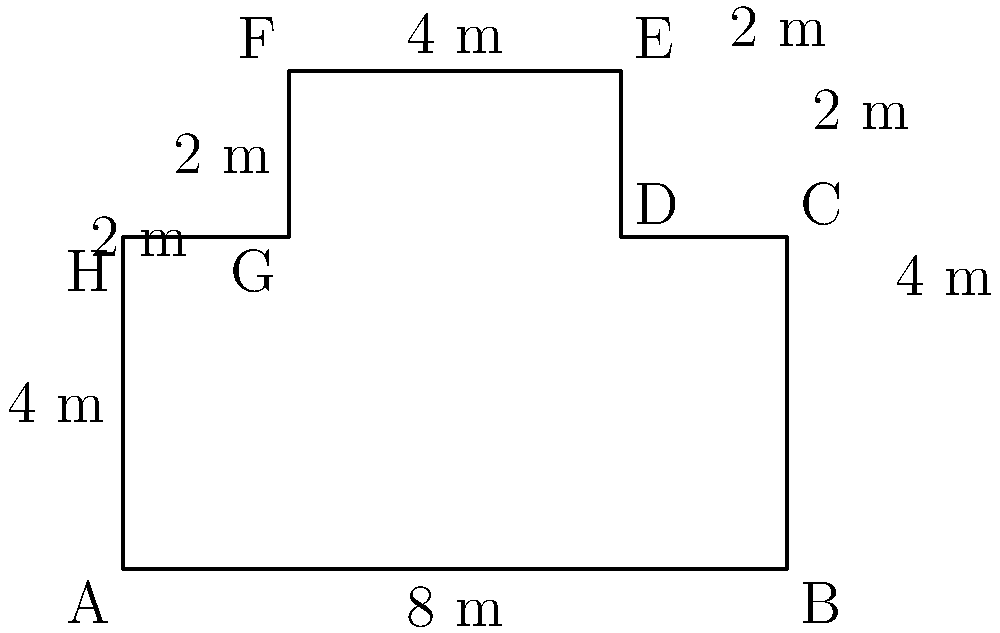As a local historian of Ribe, you're creating a simplified floor plan of Ribe Cathedral for a presentation. The plan is represented by the polygon shown above. Calculate the perimeter of this simplified floor plan in meters. To calculate the perimeter of the simplified floor plan, we need to sum up the lengths of all sides of the polygon. Let's go through this step-by-step:

1. Bottom side (AB): 8 m
2. Right side (BC): 4 m
3. Right side (CD): 2 m
4. Right side (DE): 2 m
5. Top side (EF): 4 m
6. Left side (FG): 2 m
7. Left side (GH): 2 m
8. Left side (HA): 4 m

Now, let's add all these lengths:

$$ \text{Perimeter} = 8 + 4 + 2 + 2 + 4 + 2 + 2 + 4 = 28 \text{ m} $$

Therefore, the perimeter of the simplified floor plan of Ribe Cathedral is 28 meters.
Answer: 28 m 